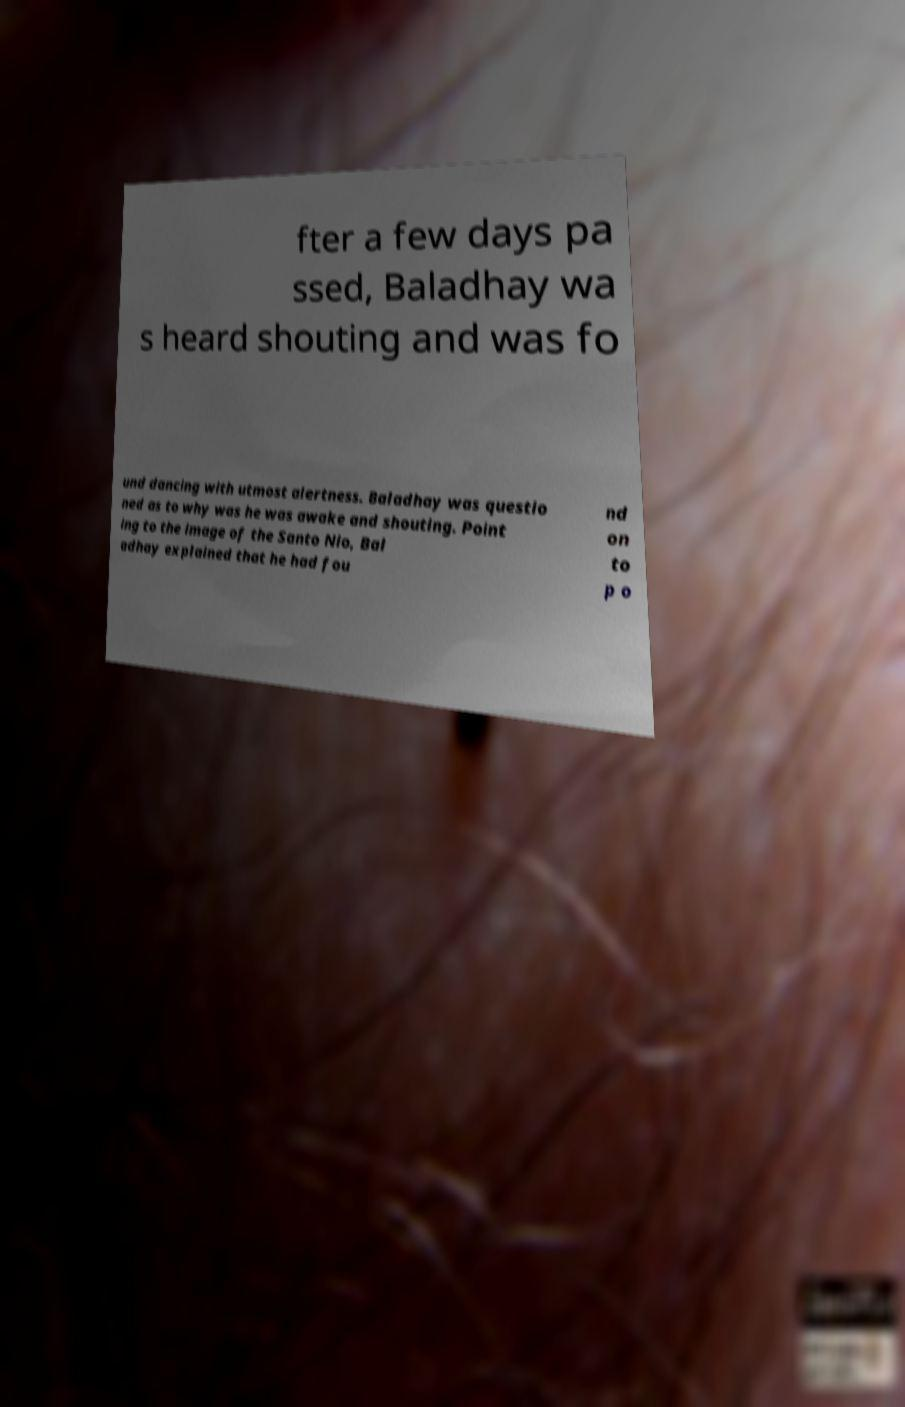Could you assist in decoding the text presented in this image and type it out clearly? fter a few days pa ssed, Baladhay wa s heard shouting and was fo und dancing with utmost alertness. Baladhay was questio ned as to why was he was awake and shouting. Point ing to the image of the Santo Nio, Bal adhay explained that he had fou nd on to p o 